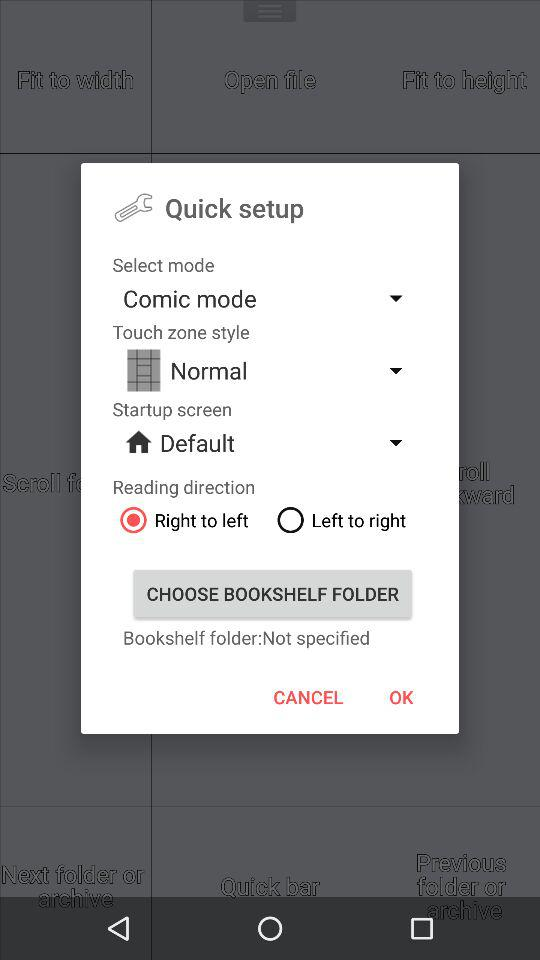Which type of startup screen is selected? The selected startup screen type is "Default". 